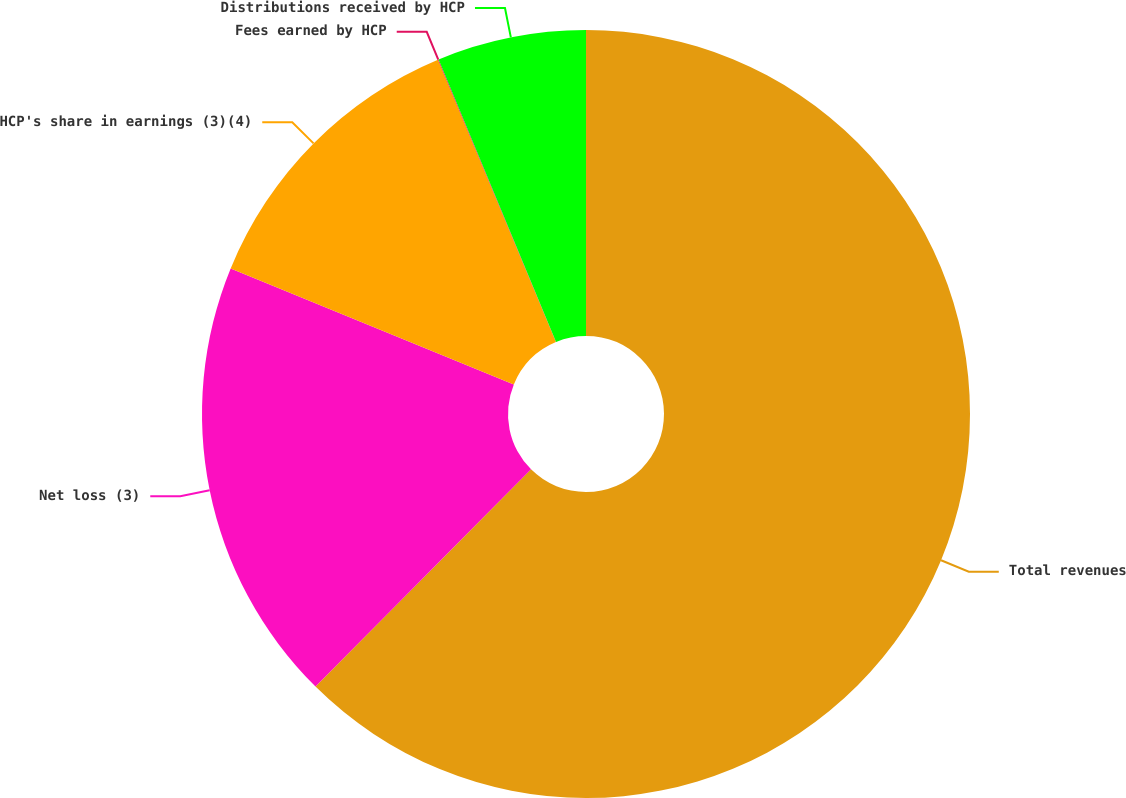Convert chart. <chart><loc_0><loc_0><loc_500><loc_500><pie_chart><fcel>Total revenues<fcel>Net loss (3)<fcel>HCP's share in earnings (3)(4)<fcel>Fees earned by HCP<fcel>Distributions received by HCP<nl><fcel>62.44%<fcel>18.75%<fcel>12.51%<fcel>0.03%<fcel>6.27%<nl></chart> 